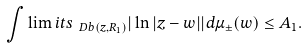<formula> <loc_0><loc_0><loc_500><loc_500>\int \lim i t s _ { \ D b ( z , R _ { 1 } ) } | \ln | z - w | | d \mu _ { \pm } ( w ) \leq A _ { 1 } .</formula> 